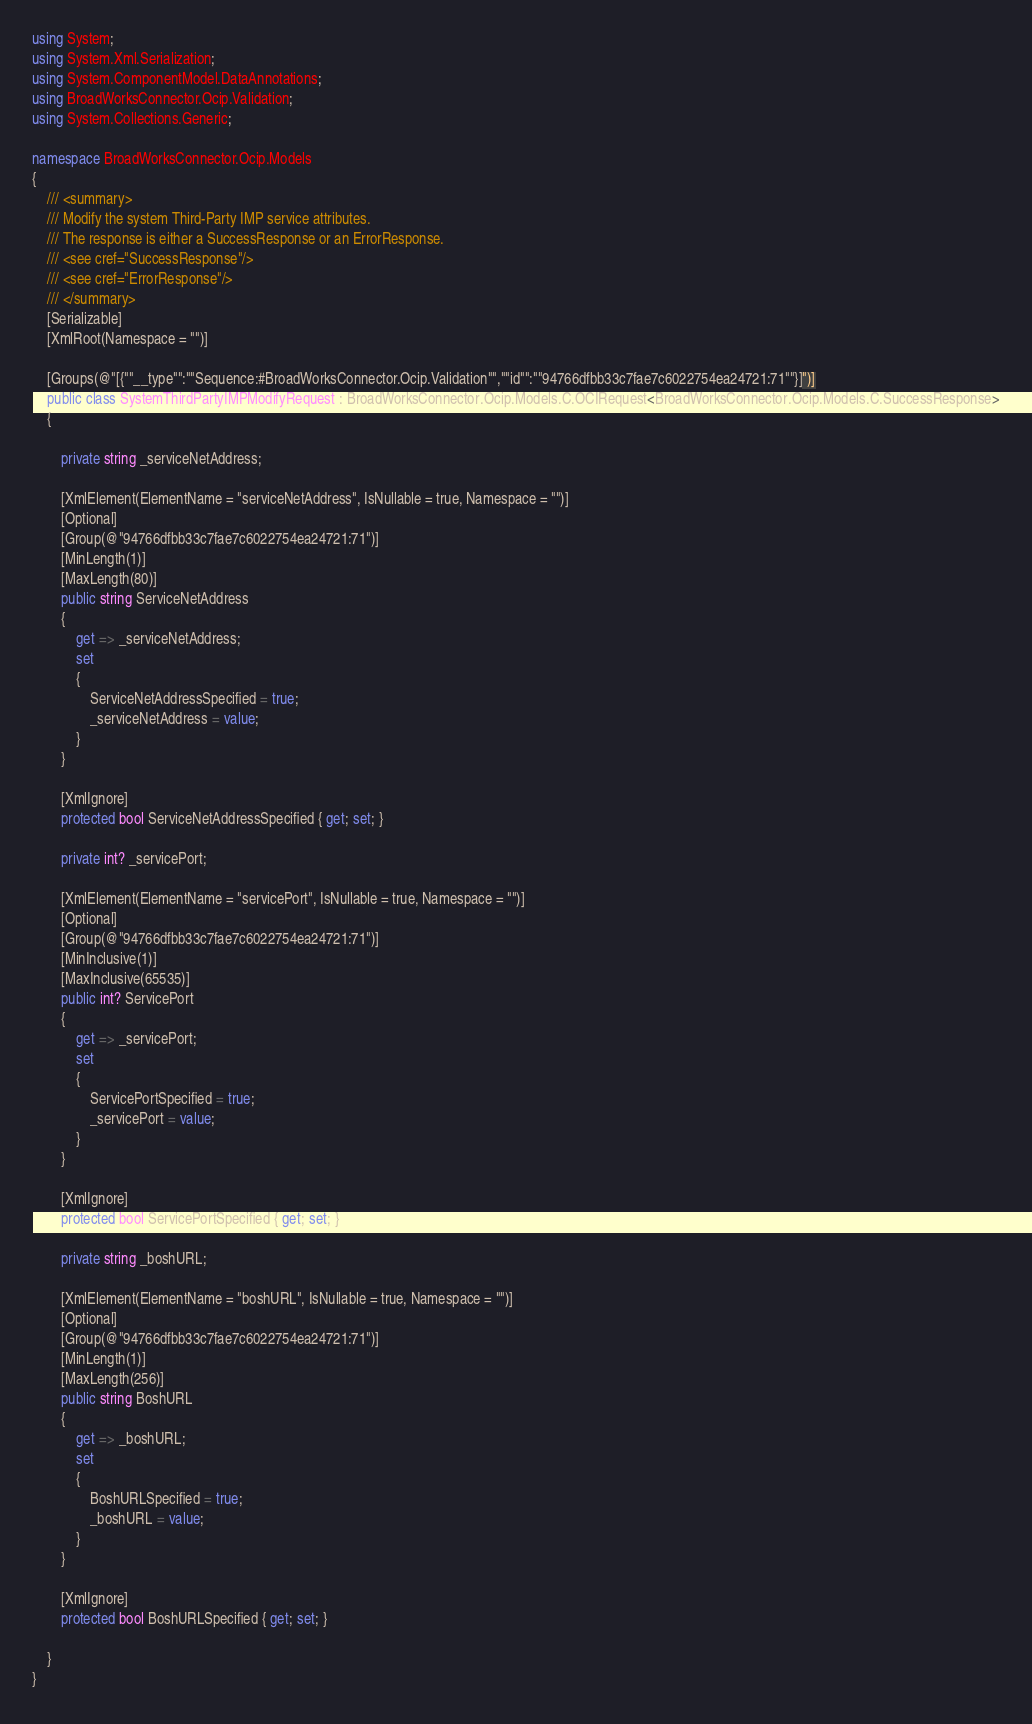<code> <loc_0><loc_0><loc_500><loc_500><_C#_>using System;
using System.Xml.Serialization;
using System.ComponentModel.DataAnnotations;
using BroadWorksConnector.Ocip.Validation;
using System.Collections.Generic;

namespace BroadWorksConnector.Ocip.Models
{
    /// <summary>
    /// Modify the system Third-Party IMP service attributes.
    /// The response is either a SuccessResponse or an ErrorResponse.
    /// <see cref="SuccessResponse"/>
    /// <see cref="ErrorResponse"/>
    /// </summary>
    [Serializable]
    [XmlRoot(Namespace = "")]

    [Groups(@"[{""__type"":""Sequence:#BroadWorksConnector.Ocip.Validation"",""id"":""94766dfbb33c7fae7c6022754ea24721:71""}]")]
    public class SystemThirdPartyIMPModifyRequest : BroadWorksConnector.Ocip.Models.C.OCIRequest<BroadWorksConnector.Ocip.Models.C.SuccessResponse>
    {

        private string _serviceNetAddress;

        [XmlElement(ElementName = "serviceNetAddress", IsNullable = true, Namespace = "")]
        [Optional]
        [Group(@"94766dfbb33c7fae7c6022754ea24721:71")]
        [MinLength(1)]
        [MaxLength(80)]
        public string ServiceNetAddress
        {
            get => _serviceNetAddress;
            set
            {
                ServiceNetAddressSpecified = true;
                _serviceNetAddress = value;
            }
        }

        [XmlIgnore]
        protected bool ServiceNetAddressSpecified { get; set; }

        private int? _servicePort;

        [XmlElement(ElementName = "servicePort", IsNullable = true, Namespace = "")]
        [Optional]
        [Group(@"94766dfbb33c7fae7c6022754ea24721:71")]
        [MinInclusive(1)]
        [MaxInclusive(65535)]
        public int? ServicePort
        {
            get => _servicePort;
            set
            {
                ServicePortSpecified = true;
                _servicePort = value;
            }
        }

        [XmlIgnore]
        protected bool ServicePortSpecified { get; set; }

        private string _boshURL;

        [XmlElement(ElementName = "boshURL", IsNullable = true, Namespace = "")]
        [Optional]
        [Group(@"94766dfbb33c7fae7c6022754ea24721:71")]
        [MinLength(1)]
        [MaxLength(256)]
        public string BoshURL
        {
            get => _boshURL;
            set
            {
                BoshURLSpecified = true;
                _boshURL = value;
            }
        }

        [XmlIgnore]
        protected bool BoshURLSpecified { get; set; }

    }
}
</code> 